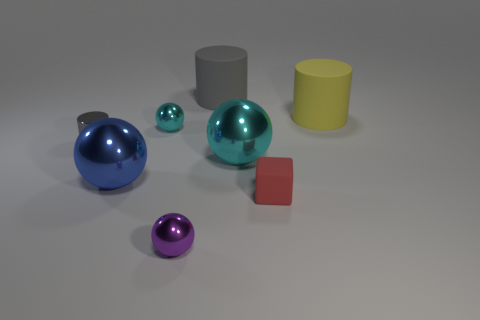The tiny metal object in front of the tiny cube is what color?
Your response must be concise. Purple. There is a large gray object on the right side of the shiny ball behind the gray cylinder that is in front of the yellow thing; what is it made of?
Your response must be concise. Rubber. There is a cyan metal ball that is to the right of the matte cylinder left of the yellow object; what size is it?
Keep it short and to the point. Large. There is another small thing that is the same shape as the yellow object; what is its color?
Give a very brief answer. Gray. What number of large cylinders are the same color as the small cylinder?
Give a very brief answer. 1. Do the yellow thing and the red thing have the same size?
Give a very brief answer. No. What material is the small cylinder?
Make the answer very short. Metal. There is a small cylinder that is made of the same material as the small cyan ball; what color is it?
Keep it short and to the point. Gray. Is the material of the blue ball the same as the gray object to the right of the tiny cylinder?
Make the answer very short. No. How many large yellow things are the same material as the large gray cylinder?
Keep it short and to the point. 1. 